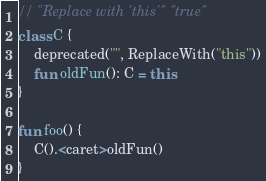Convert code to text. <code><loc_0><loc_0><loc_500><loc_500><_Kotlin_>// "Replace with 'this'" "true"
class C {
    deprecated("", ReplaceWith("this"))
    fun oldFun(): C = this
}

fun foo() {
    C().<caret>oldFun()
}
</code> 